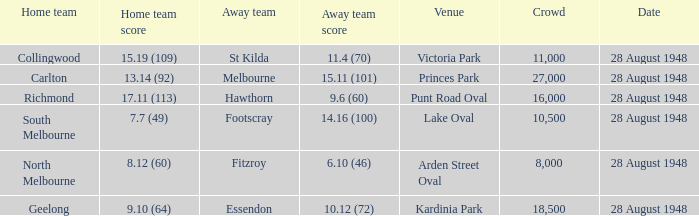12 (60)? North Melbourne. 